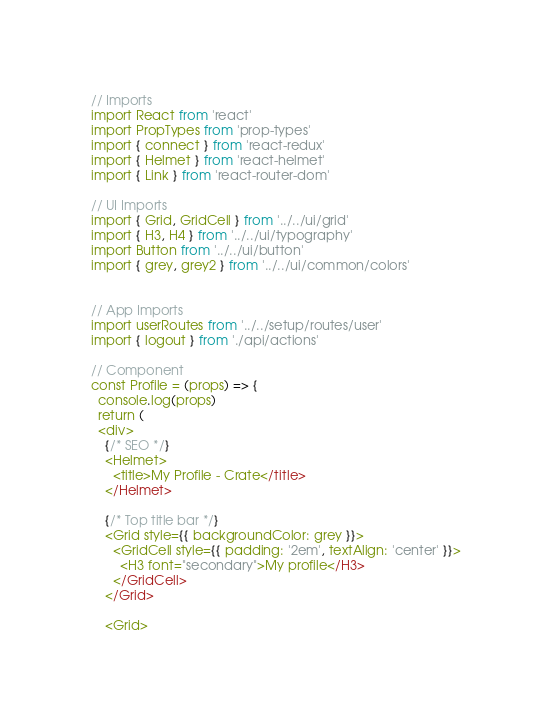Convert code to text. <code><loc_0><loc_0><loc_500><loc_500><_JavaScript_>// Imports
import React from 'react'
import PropTypes from 'prop-types'
import { connect } from 'react-redux'
import { Helmet } from 'react-helmet'
import { Link } from 'react-router-dom'

// UI Imports
import { Grid, GridCell } from '../../ui/grid'
import { H3, H4 } from '../../ui/typography'
import Button from '../../ui/button'
import { grey, grey2 } from '../../ui/common/colors'


// App Imports
import userRoutes from '../../setup/routes/user'
import { logout } from './api/actions'

// Component
const Profile = (props) => {
  console.log(props)
  return (
  <div>
    {/* SEO */}
    <Helmet>
      <title>My Profile - Crate</title>
    </Helmet>

    {/* Top title bar */}
    <Grid style={{ backgroundColor: grey }}>
      <GridCell style={{ padding: '2em', textAlign: 'center' }}>
        <H3 font="secondary">My profile</H3>
      </GridCell>
    </Grid>

    <Grid></code> 